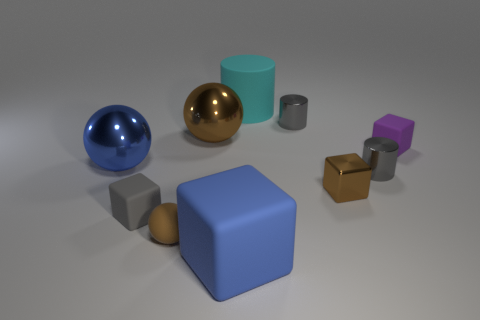Subtract all shiny balls. How many balls are left? 1 Subtract all cyan cylinders. How many cylinders are left? 2 Subtract 0 red blocks. How many objects are left? 10 Subtract all cylinders. How many objects are left? 7 Subtract 1 balls. How many balls are left? 2 Subtract all cyan cubes. Subtract all yellow cylinders. How many cubes are left? 4 Subtract all purple blocks. How many gray cylinders are left? 2 Subtract all tiny metal things. Subtract all blue metallic things. How many objects are left? 6 Add 6 small rubber balls. How many small rubber balls are left? 7 Add 6 gray matte objects. How many gray matte objects exist? 7 